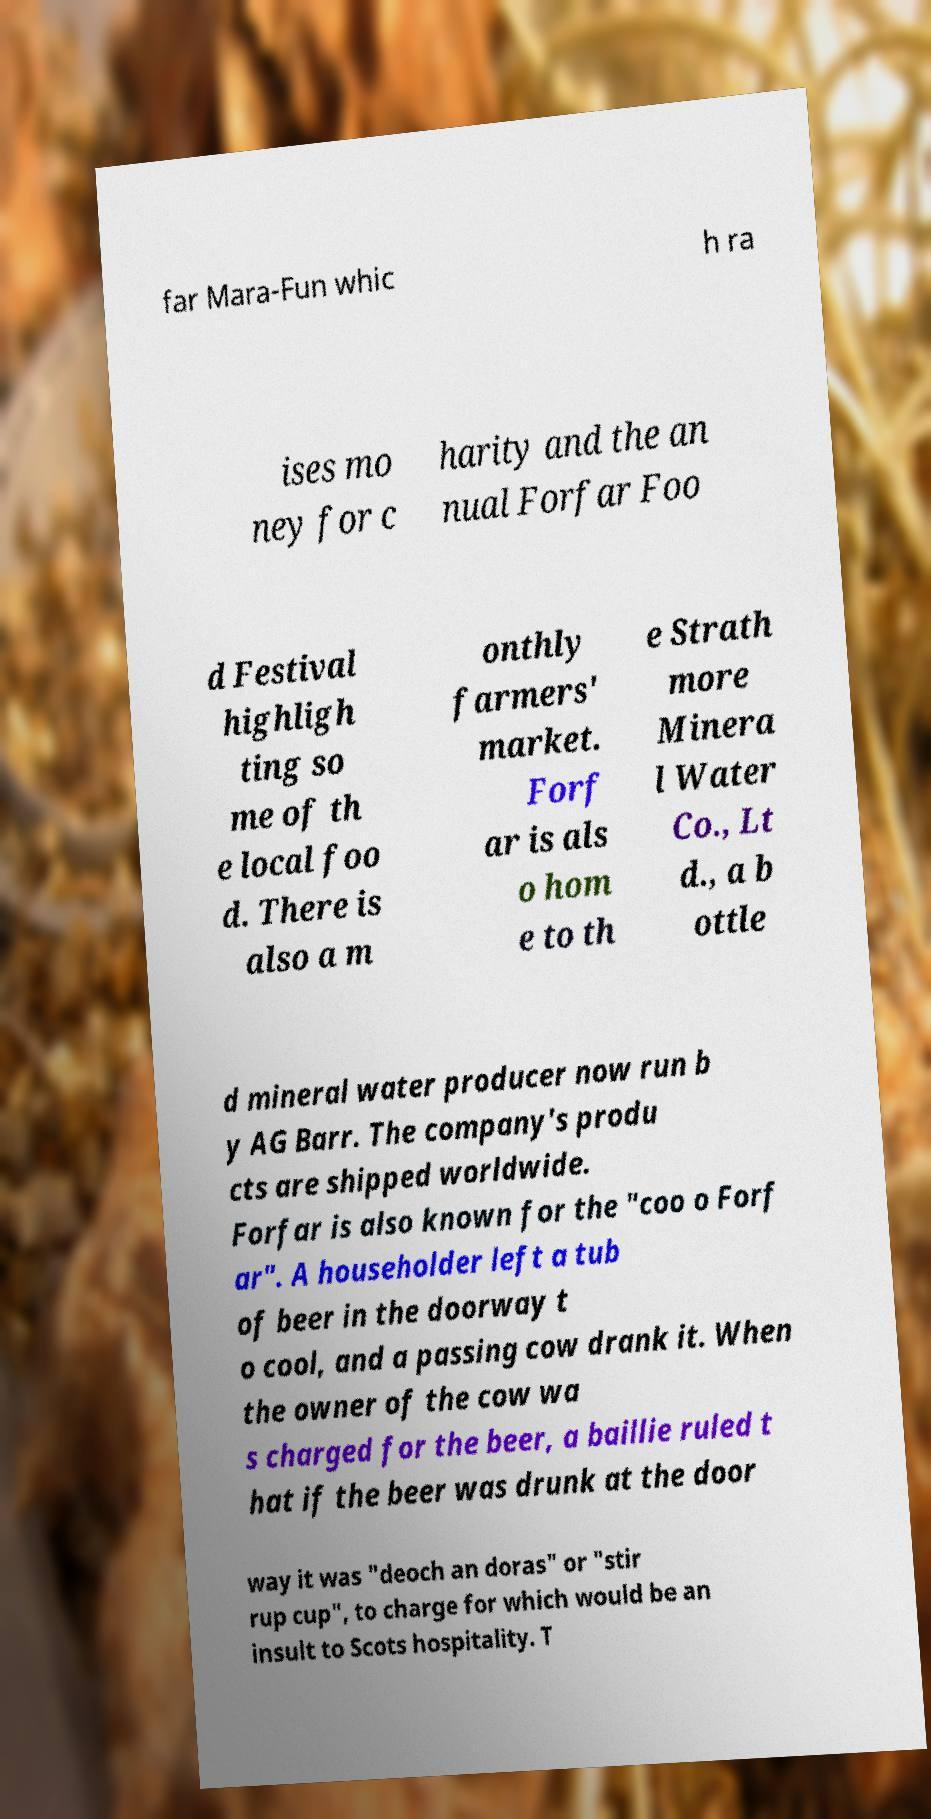I need the written content from this picture converted into text. Can you do that? far Mara-Fun whic h ra ises mo ney for c harity and the an nual Forfar Foo d Festival highligh ting so me of th e local foo d. There is also a m onthly farmers' market. Forf ar is als o hom e to th e Strath more Minera l Water Co., Lt d., a b ottle d mineral water producer now run b y AG Barr. The company's produ cts are shipped worldwide. Forfar is also known for the "coo o Forf ar". A householder left a tub of beer in the doorway t o cool, and a passing cow drank it. When the owner of the cow wa s charged for the beer, a baillie ruled t hat if the beer was drunk at the door way it was "deoch an doras" or "stir rup cup", to charge for which would be an insult to Scots hospitality. T 